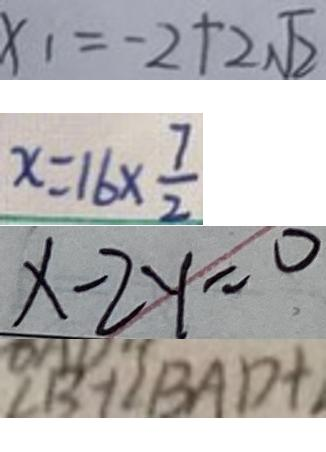<formula> <loc_0><loc_0><loc_500><loc_500>x _ { 1 } = - 2 + 2 \sqrt { 2 } 
 x = 1 6 \times \frac { 7 } { 2 } 
 x - 2 y = 0 
 \angle B + \angle B A D +</formula> 